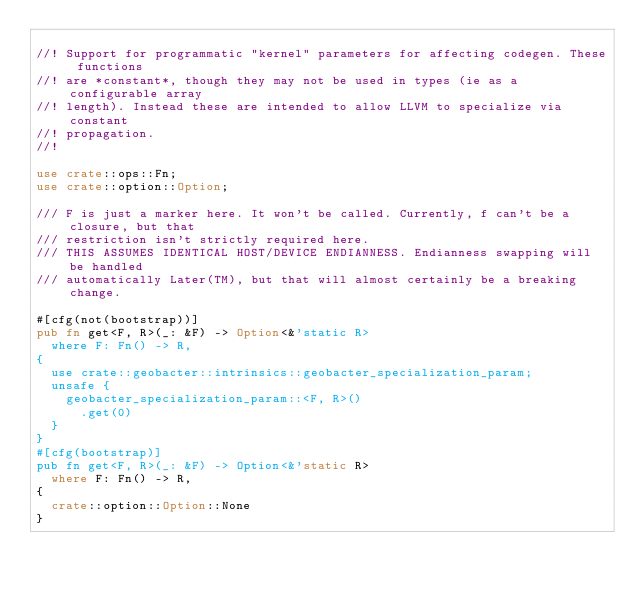Convert code to text. <code><loc_0><loc_0><loc_500><loc_500><_Rust_>
//! Support for programmatic "kernel" parameters for affecting codegen. These functions
//! are *constant*, though they may not be used in types (ie as a configurable array
//! length). Instead these are intended to allow LLVM to specialize via constant
//! propagation.
//!

use crate::ops::Fn;
use crate::option::Option;

/// F is just a marker here. It won't be called. Currently, f can't be a closure, but that
/// restriction isn't strictly required here.
/// THIS ASSUMES IDENTICAL HOST/DEVICE ENDIANNESS. Endianness swapping will be handled
/// automatically Later(TM), but that will almost certainly be a breaking change.

#[cfg(not(bootstrap))]
pub fn get<F, R>(_: &F) -> Option<&'static R>
  where F: Fn() -> R,
{
  use crate::geobacter::intrinsics::geobacter_specialization_param;
  unsafe {
    geobacter_specialization_param::<F, R>()
      .get(0)
  }
}
#[cfg(bootstrap)]
pub fn get<F, R>(_: &F) -> Option<&'static R>
  where F: Fn() -> R,
{
  crate::option::Option::None
}
</code> 